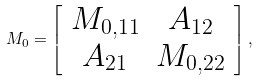Convert formula to latex. <formula><loc_0><loc_0><loc_500><loc_500>M _ { 0 } = \left [ \begin{array} { c c } M _ { 0 , 1 1 } & A _ { 1 2 } \\ A _ { 2 1 } & { M } _ { 0 , 2 2 } \\ \end{array} \right ] ,</formula> 